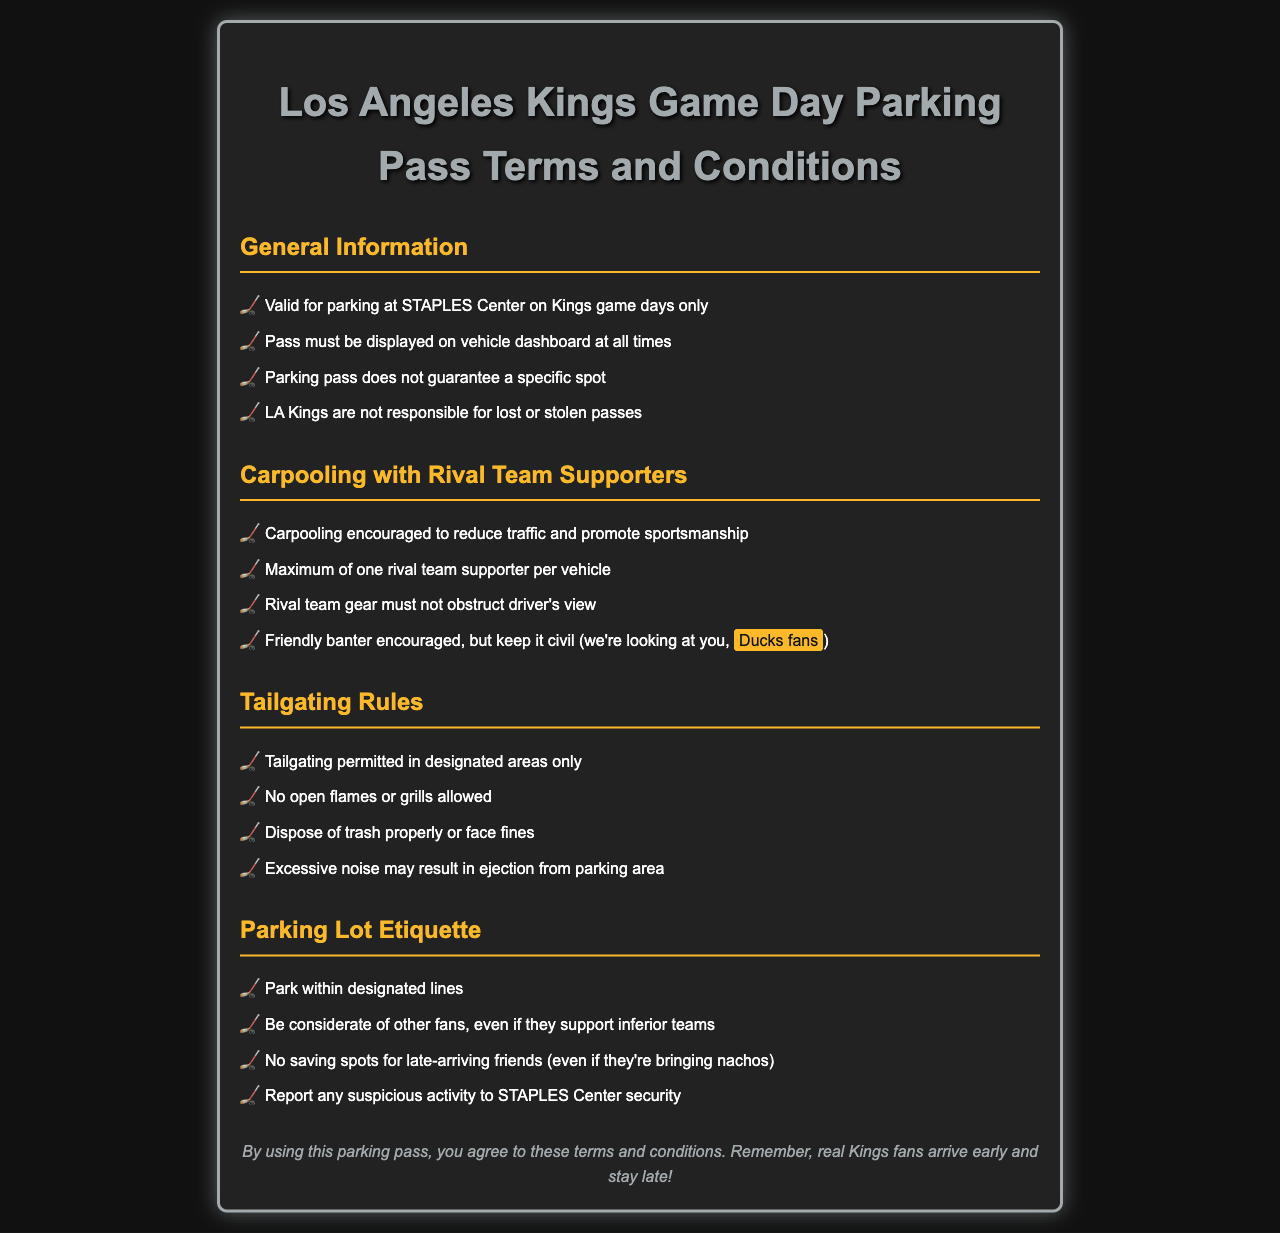What is the parking pass valid for? The parking pass is valid for parking at STAPLES Center on Kings game days only.
Answer: Parking at STAPLES Center on Kings game days only What must be displayed on the vehicle at all times? The pass must be displayed on the vehicle dashboard at all times.
Answer: Pass How many rival team supporters are allowed per vehicle? The maximum number of rival team supporters allowed per vehicle is one.
Answer: One What is encouraged while carpooling with rival team supporters? Carpooling is encouraged to reduce traffic and promote sportsmanship.
Answer: Sportsmanship What may result in ejection from the parking area? Excessive noise may result in ejection from the parking area.
Answer: Excessive noise What should you do with trash? You should dispose of trash properly or face fines.
Answer: Dispose of trash properly What is the consequence of saving spots for late-arriving friends? No saving spots for late-arriving friends (even if they're bringing nachos).
Answer: No saving spots What should you do if you see suspicious activity? You should report any suspicious activity to STAPLES Center security.
Answer: Report to security 